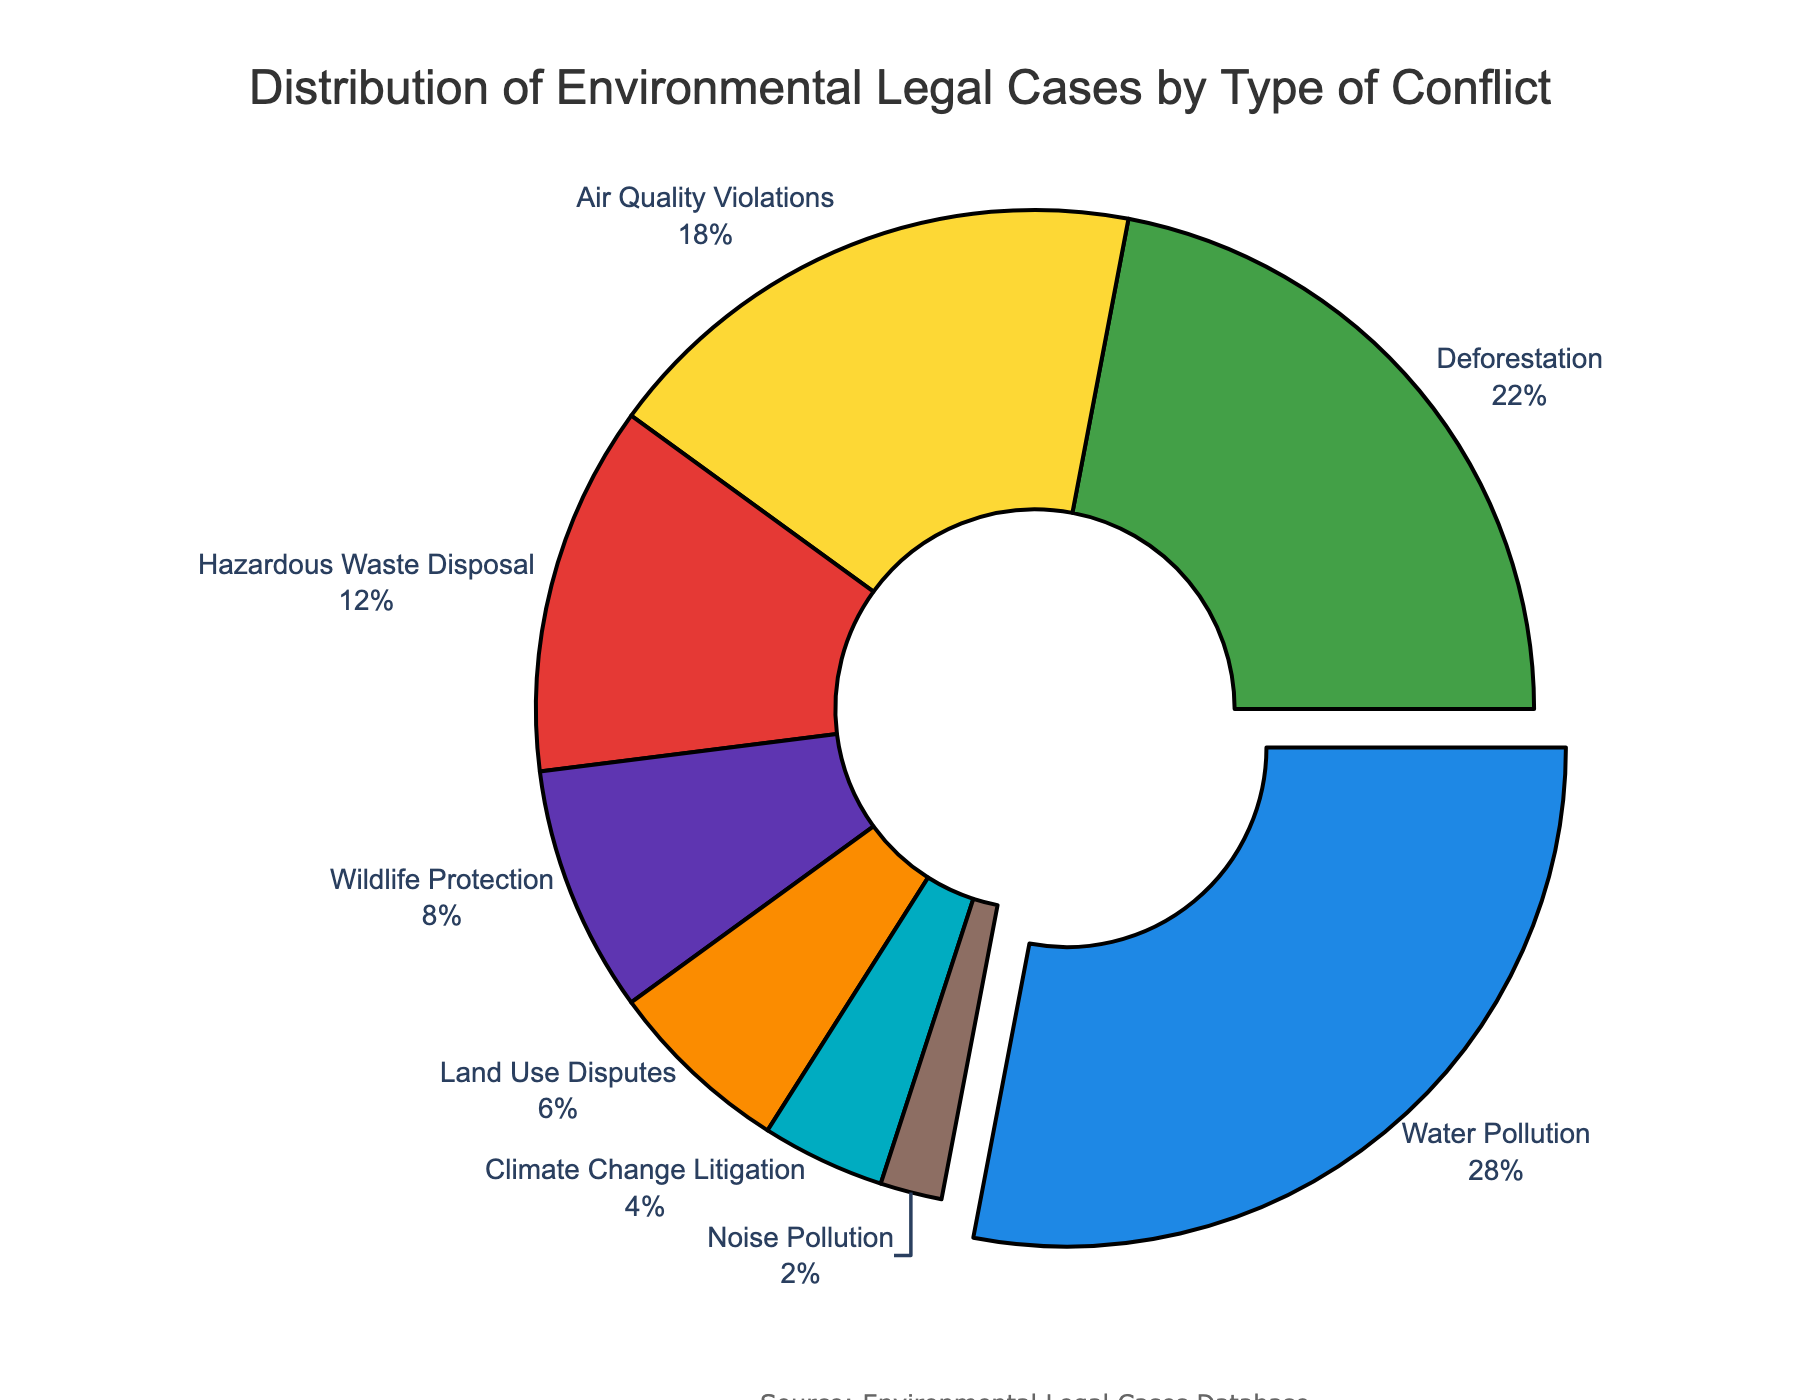Which type of environmental conflict has the highest percentage of legal cases? From the pie chart, "Water Pollution" has the largest segment highlighted by being slightly pulled out from the pie, and it shows 28%, which is the highest percentage.
Answer: Water Pollution How much higher is the percentage of Deforestation cases compared to Climate Change Litigation cases? The pie chart shows that Deforestation cases are 22% and Climate Change Litigation cases are 4%. To find the difference: 22% - 4% = 18%.
Answer: 18% What is the combined percentage of Air Quality Violations and Hazardous Waste Disposal cases? From the chart, "Air Quality Violations" is 18% and "Hazardous Waste Disposal" is 12%. Adding these two percentages gives: 18% + 12% = 30%.
Answer: 30% Which environmental conflict has the lowest percentage of legal cases, and what is that percentage? The pie chart shows that "Noise Pollution" has the smallest segment with a percentage of 2%, indicating it has the lowest percentage of legal cases.
Answer: Noise Pollution, 2% Are there more legal cases related to Wildlife Protection or Land Use Disputes, and by how much? The pie chart shows 8% for Wildlife Protection and 6% for Land Use Disputes. To find which one is higher and by how much: 8% - 6% = 2%. So, there are 2% more cases related to Wildlife Protection.
Answer: Wildlife Protection, 2% What proportion of the total are cases related to "Water Pollution", "Deforestation", and "Air Quality Violations" combined? Adding the percentages from the pie chart for these categories: Water Pollution (28%), Deforestation (22%), and Air Quality Violations (18%) gives: 28% + 22% + 18% = 68%.
Answer: 68% How does the percentage of Land Use Disputes compare to that of Hazardous Waste Disposal? The pie chart shows Land Use Disputes at 6% and Hazardous Waste Disposal at 12%. Comparing these percentages, we see that Land Use Disputes have half the percentage of Hazardous Waste Disposal: 6% < 12%.
Answer: Land Use Disputes, less What is the difference in percentage between the highest and lowest conflict types in the chart? The highest percentage is for Water Pollution at 28%, and the lowest is for Noise Pollution at 2%. The difference is 28% - 2% = 26%.
Answer: 26% Which three types of conflicts cumulatively account for less than 10% of the cases? The pie chart indicates that Climate Change Litigation is 4%, and Noise Pollution is 2%. These two sum up to 6%, which is still less than 10%. No other individual percentage in the chart is small enough to keep the combined total under 10%. Noise Pollution (2%) and Climate Change Litigation (4%) add to 6%, below 10%.
Answer: Climate Change Litigation, Noise Pollution If you were to remove Water Pollution cases, what would be the combined percentage of Deforestation and Air Quality Violations compared to the total remaining cases? Without Water Pollution, the total percentage left is 100% - 28% = 72%. Adding Deforestation (22%) and Air Quality Violations (18%) gives 40%. Therefore, the new percentage proportion is (40/72) * 100% = 55.56%.
Answer: 55.56% 